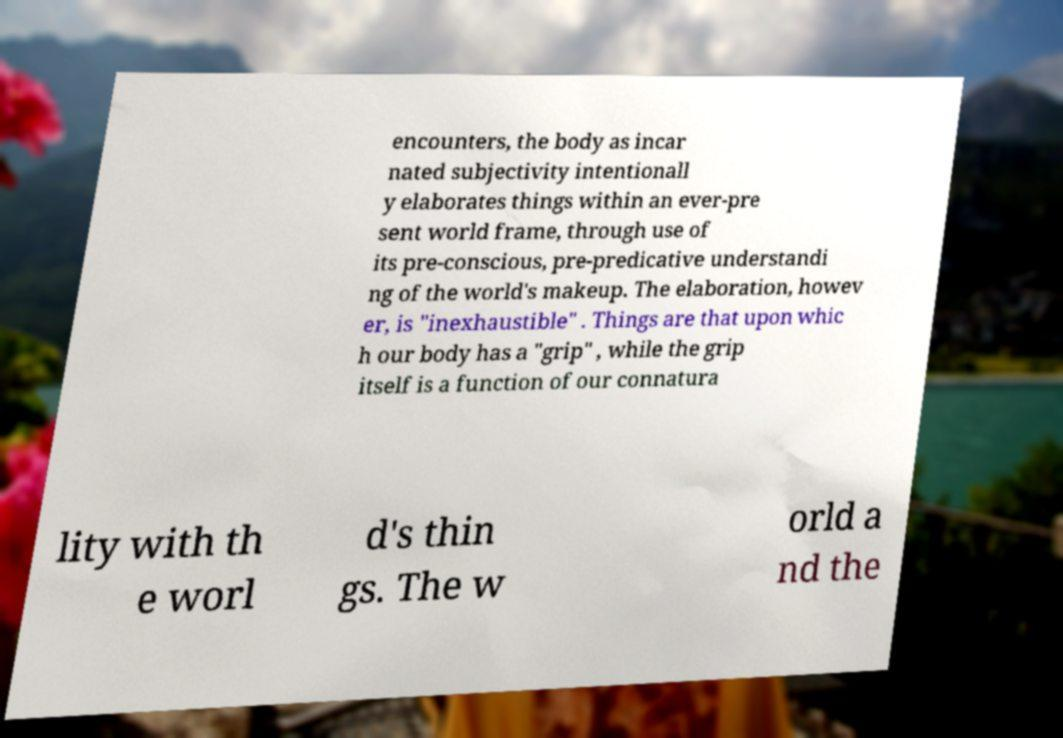Can you read and provide the text displayed in the image?This photo seems to have some interesting text. Can you extract and type it out for me? encounters, the body as incar nated subjectivity intentionall y elaborates things within an ever-pre sent world frame, through use of its pre-conscious, pre-predicative understandi ng of the world's makeup. The elaboration, howev er, is "inexhaustible" . Things are that upon whic h our body has a "grip" , while the grip itself is a function of our connatura lity with th e worl d's thin gs. The w orld a nd the 